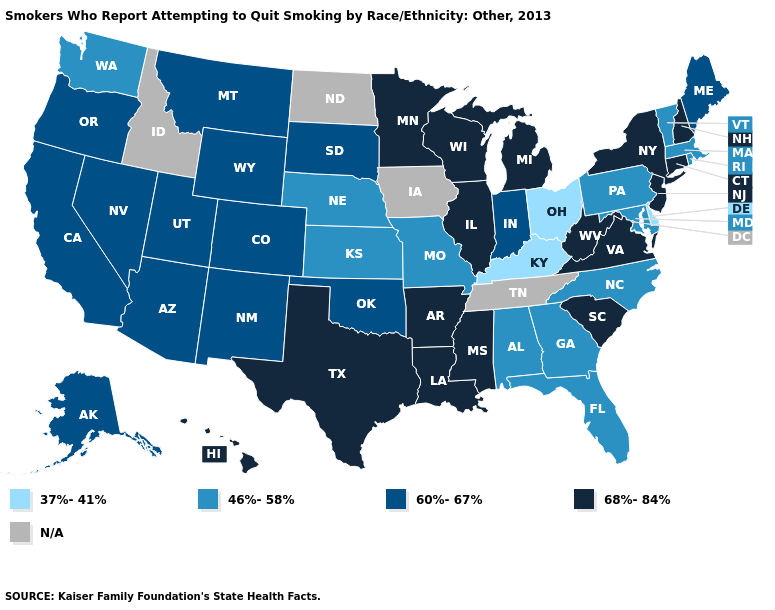Among the states that border Kentucky , does Missouri have the lowest value?
Be succinct. No. Does Ohio have the highest value in the MidWest?
Concise answer only. No. What is the highest value in the MidWest ?
Quick response, please. 68%-84%. Which states have the lowest value in the South?
Concise answer only. Delaware, Kentucky. Name the states that have a value in the range 46%-58%?
Concise answer only. Alabama, Florida, Georgia, Kansas, Maryland, Massachusetts, Missouri, Nebraska, North Carolina, Pennsylvania, Rhode Island, Vermont, Washington. Which states have the lowest value in the Northeast?
Quick response, please. Massachusetts, Pennsylvania, Rhode Island, Vermont. Name the states that have a value in the range 37%-41%?
Write a very short answer. Delaware, Kentucky, Ohio. What is the highest value in the West ?
Be succinct. 68%-84%. How many symbols are there in the legend?
Be succinct. 5. Name the states that have a value in the range 60%-67%?
Answer briefly. Alaska, Arizona, California, Colorado, Indiana, Maine, Montana, Nevada, New Mexico, Oklahoma, Oregon, South Dakota, Utah, Wyoming. Among the states that border Iowa , which have the highest value?
Write a very short answer. Illinois, Minnesota, Wisconsin. Among the states that border Florida , which have the highest value?
Answer briefly. Alabama, Georgia. Name the states that have a value in the range 46%-58%?
Be succinct. Alabama, Florida, Georgia, Kansas, Maryland, Massachusetts, Missouri, Nebraska, North Carolina, Pennsylvania, Rhode Island, Vermont, Washington. Which states have the highest value in the USA?
Quick response, please. Arkansas, Connecticut, Hawaii, Illinois, Louisiana, Michigan, Minnesota, Mississippi, New Hampshire, New Jersey, New York, South Carolina, Texas, Virginia, West Virginia, Wisconsin. What is the lowest value in the USA?
Keep it brief. 37%-41%. 